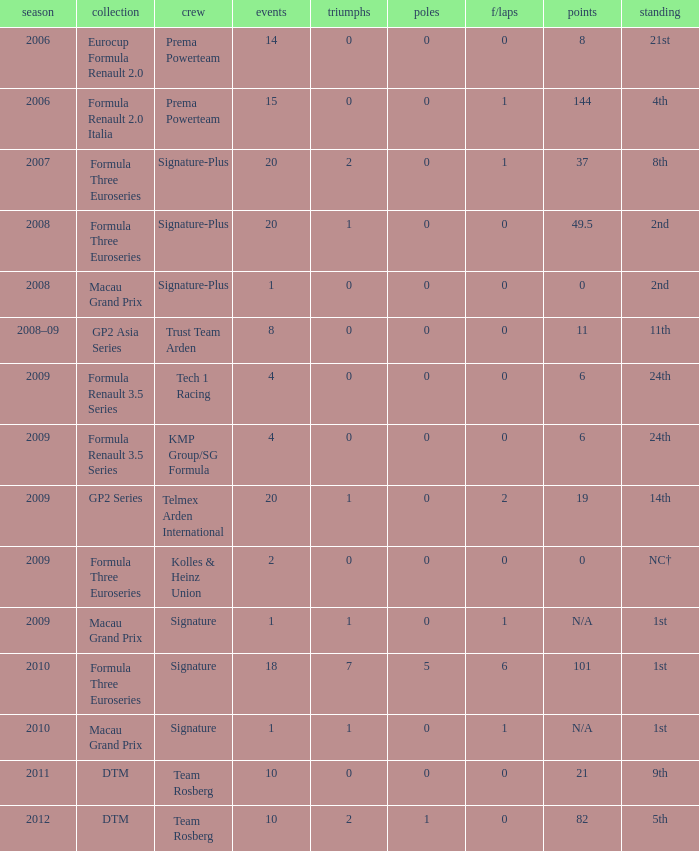How many races did the Formula Three Euroseries signature team have? 18.0. 